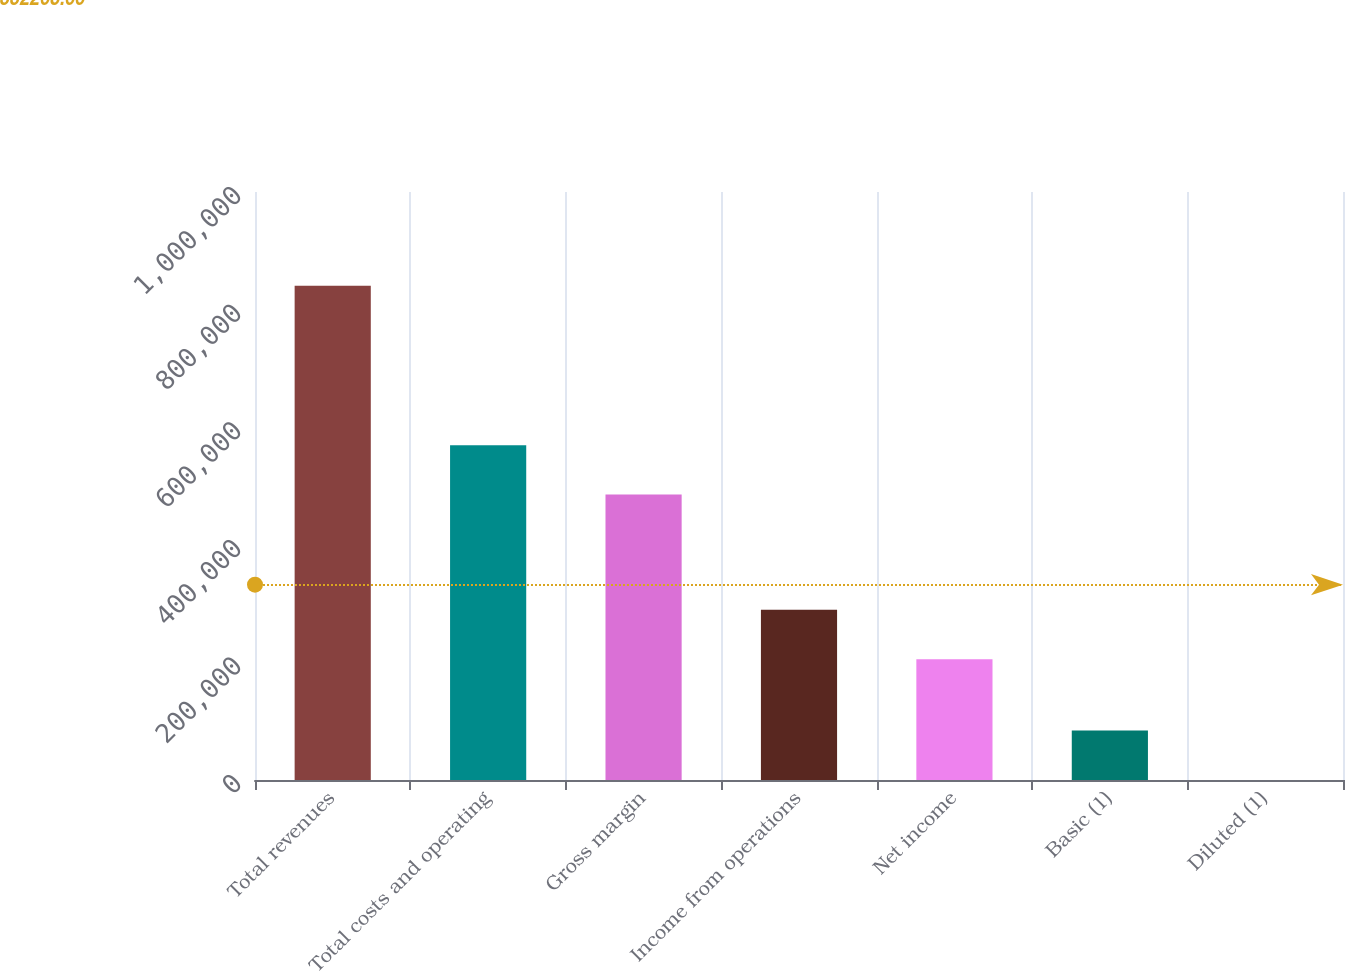<chart> <loc_0><loc_0><loc_500><loc_500><bar_chart><fcel>Total revenues<fcel>Total costs and operating<fcel>Gross margin<fcel>Income from operations<fcel>Net income<fcel>Basic (1)<fcel>Diluted (1)<nl><fcel>840521<fcel>569424<fcel>485372<fcel>289398<fcel>205346<fcel>84053.2<fcel>1.21<nl></chart> 